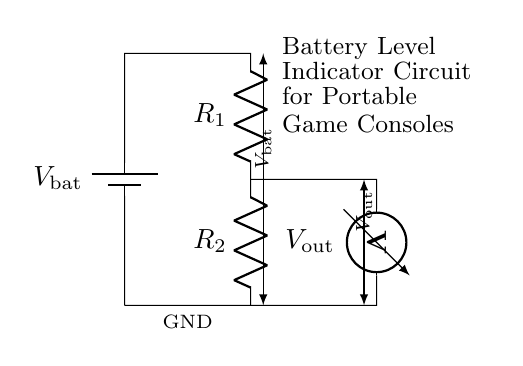What type of circuit is this? This is a voltage divider circuit, as evidenced by the arrangement of two resistors in series connected to a voltage source, producing an output voltage that is a fraction of the input voltage.
Answer: Voltage Divider What components are present in this circuit? The circuit includes a battery, two resistors, and a voltmeter. The battery provides the source voltage, while the resistors and voltmeter show how the voltage is divided.
Answer: Battery, Resistors, Voltmeter What is the function of the voltmeter in this circuit? The voltmeter measures the output voltage across one of the resistors (or both), providing a reading of the voltage level that reflects the battery's state.
Answer: Voltage measurement How does the output voltage relate to the input voltage? The output voltage is determined by the voltage divider formula, which states that Vout equals Vin multiplied by the ratio of R2 over the total resistance (R1 + R2). This relationship allows for a specific output voltage based on the resistor values.
Answer: Vout = Vin * (R2 / (R1 + R2)) If R1 equals 10k and R2 equals 20k, what is the expected output voltage if the battery is 9V? To find the output voltage, apply the voltage divider formula: Vout = 9V * (20k / (10k + 20k)) = 9V * (20/30) = 6V. This calculation shows how the resistors divide the total input voltage to produce a lower output voltage.
Answer: 6V What happens to the output voltage if R1 is increased while keeping R2 constant? If R1 increases, the total resistance increases which leads to a decrease in the output voltage according to the voltage divider principle. More resistance in R1 means less voltage drop across R2, thus reducing Vout.
Answer: Decreases 